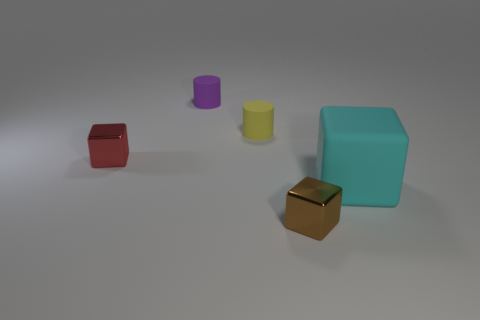The tiny thing that is both right of the small red shiny object and in front of the yellow object has what shape?
Keep it short and to the point. Cube. Is there a small yellow thing of the same shape as the purple matte object?
Give a very brief answer. Yes. Do the metal thing that is to the right of the red metal block and the rubber thing in front of the red block have the same size?
Make the answer very short. No. Is the number of cyan rubber things greater than the number of big yellow rubber spheres?
Your response must be concise. Yes. What number of tiny brown objects are made of the same material as the yellow thing?
Offer a terse response. 0. Is the shape of the red thing the same as the cyan thing?
Keep it short and to the point. Yes. What size is the rubber thing that is in front of the metal thing on the left side of the metallic object that is to the right of the red shiny cube?
Provide a short and direct response. Large. There is a small metallic thing that is in front of the big cyan matte block; are there any big cyan matte objects behind it?
Make the answer very short. Yes. There is a small metallic thing that is left of the tiny cube in front of the small red shiny thing; how many small brown metallic blocks are in front of it?
Give a very brief answer. 1. What color is the small object that is both in front of the yellow object and on the right side of the small purple thing?
Give a very brief answer. Brown. 